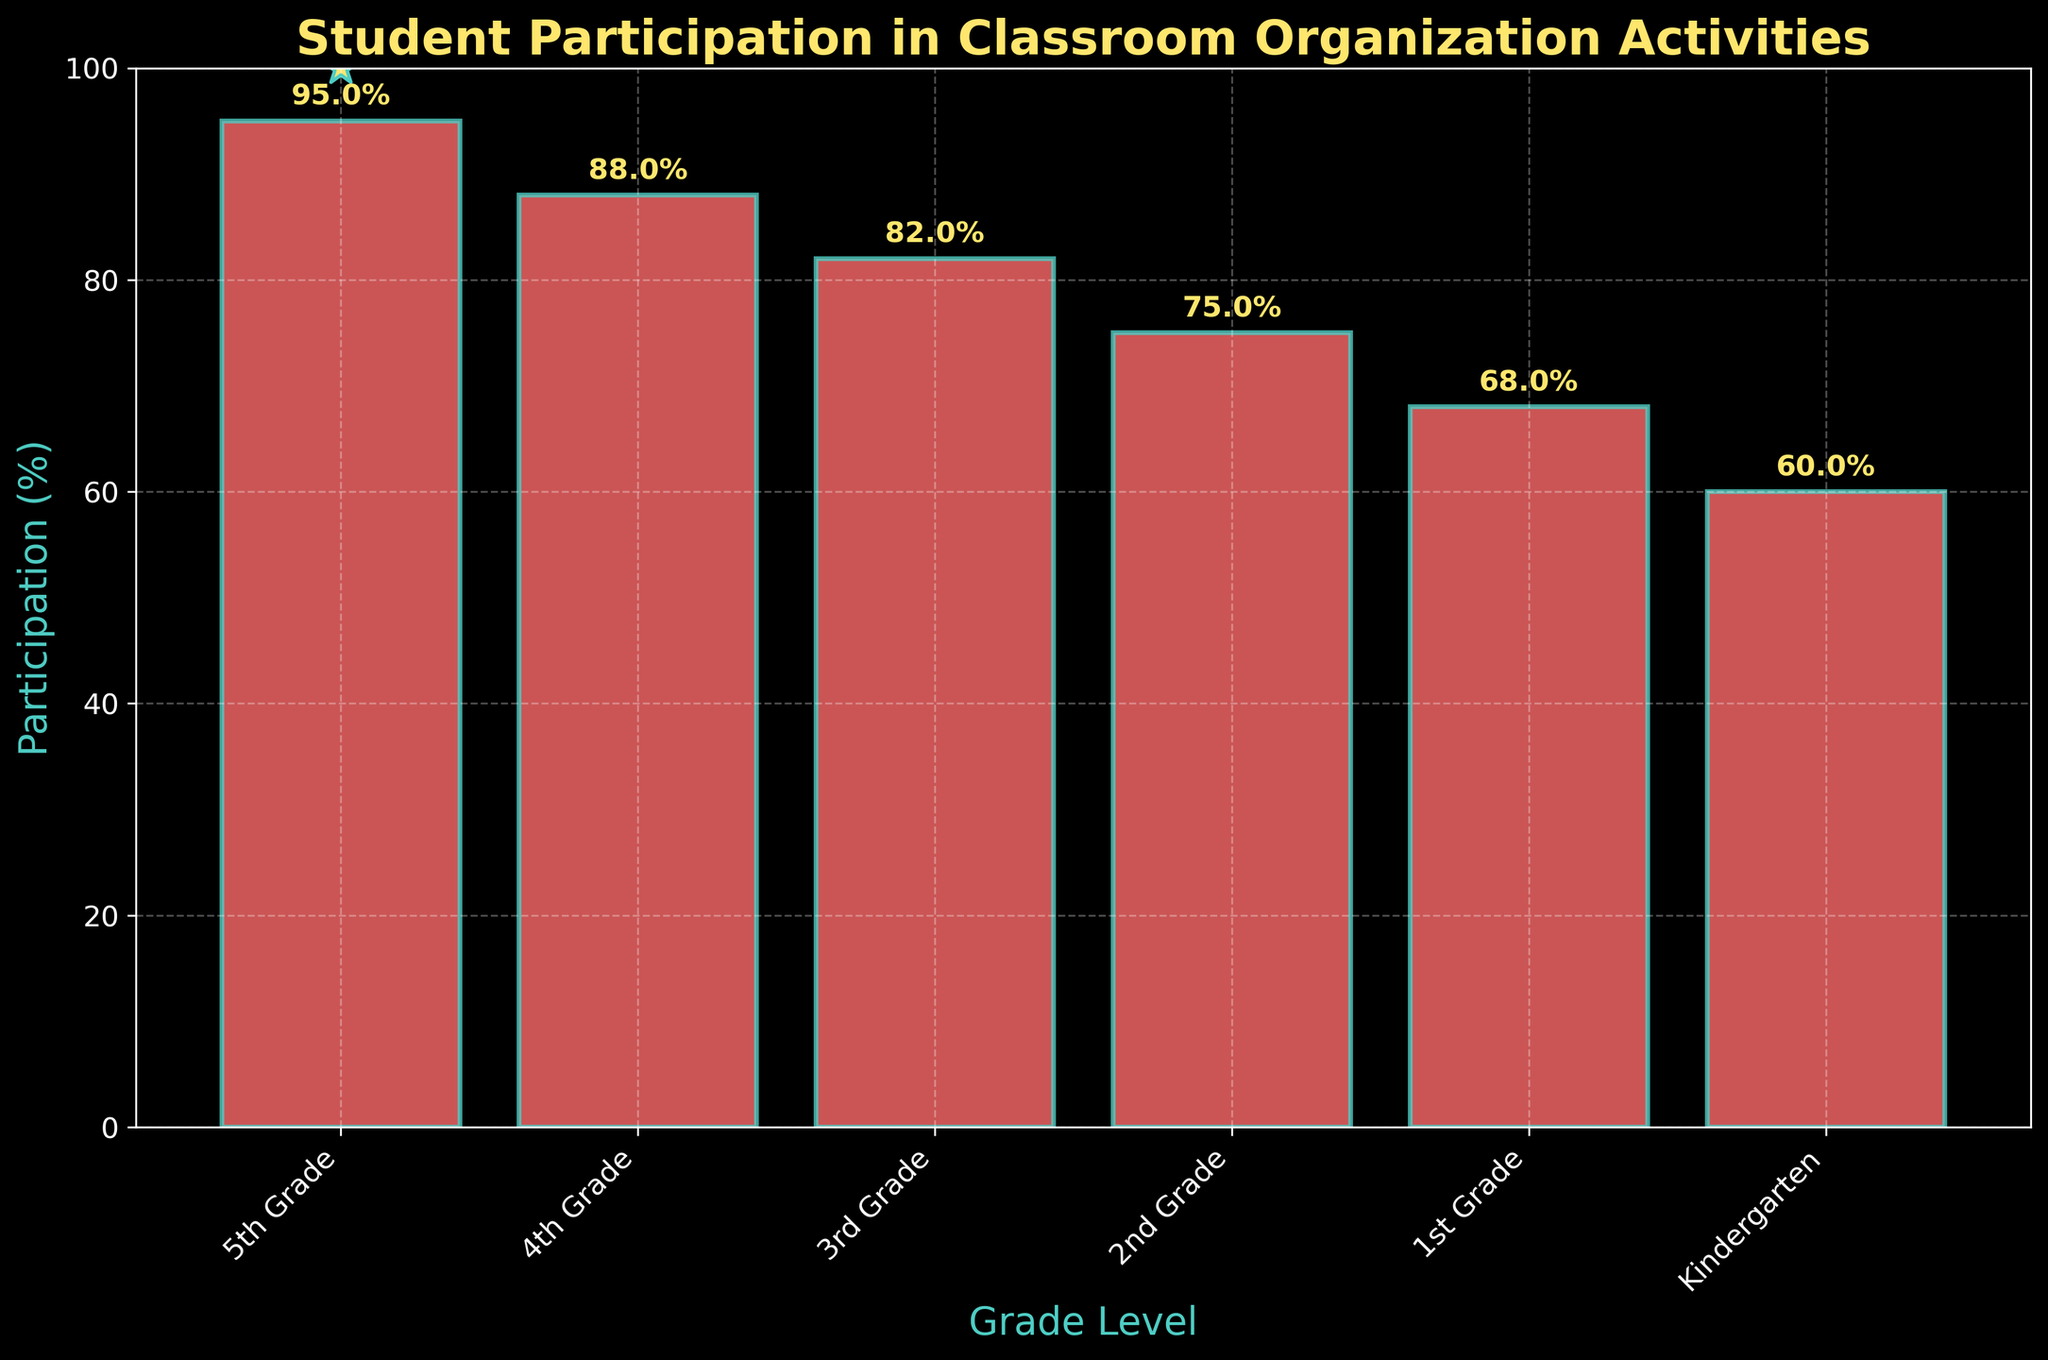What is the title of the figure? The title is usually located at the top of the figure. In this case, it is clear from the visually distinct larger, bold font emphasizing the main subject of the graphic.
Answer: Student Participation in Classroom Organization Activities What is the participation percentage for 4th Grade? First, locate the '4th Grade' bar along the x-axis. Then, look at the top of the bar to see the percentage label.
Answer: 88% Which grade has the lowest student participation percentage? By examining the heights of the bars, the shortest bar indicates the lowest percentage.
Answer: Kindergarten What is the difference in participation percentages between 5th Grade and Kindergarten? The 5th Grade participation percentage is 95%, and Kindergarten is 60%. Subtract 60 from 95 to find the difference.
Answer: 35% What does the starred marker on some grades represent? The stars are added for aesthetic emphasis, usually indicating a notable feature. Here they are on the 5th Grade bar, reflecting high participation. The exact qualifying criteria can be inferred from the plot.
Answer: Participation >= 90% Calculate the average participation percentage for all the grades. Sum all the participation percentages (95 + 88 + 82 + 75 + 68 + 60) and divide by the number of grades (6).
Answer: 78% Which two consecutive grades have the smallest decrease in participation percentages? Calculate the decrease between each pair by subtracting the later grade percentage from the earlier grade percentage. Compare to find the smallest decrease.
Answer: 4th Grade and 3rd Grade (88% - 82% = 6%) What is the participation trend among the different grade levels? Observing the bar heights from Kindergarten to 5th Grade shows whether the participation increases or decreases.
Answer: Increases from Kindergarten to 5th Grade What are the colors used for the bars and the text annotations? The bar color and text can be identified visually based on distinct characteristics. The bars are red while the text annotations and some details are yellow.
Answer: Bars: Red; Text: Yellow 